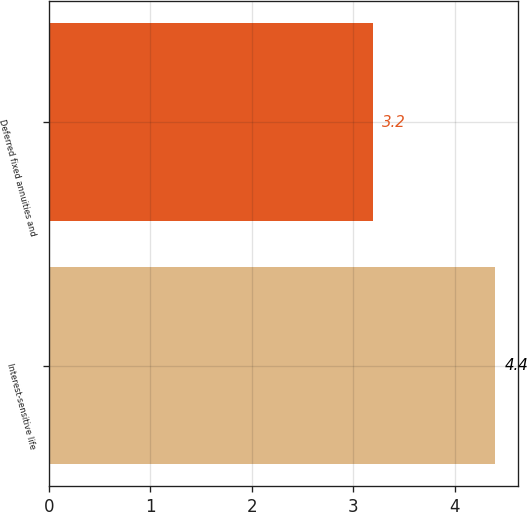Convert chart to OTSL. <chart><loc_0><loc_0><loc_500><loc_500><bar_chart><fcel>Interest-sensitive life<fcel>Deferred fixed annuities and<nl><fcel>4.4<fcel>3.2<nl></chart> 